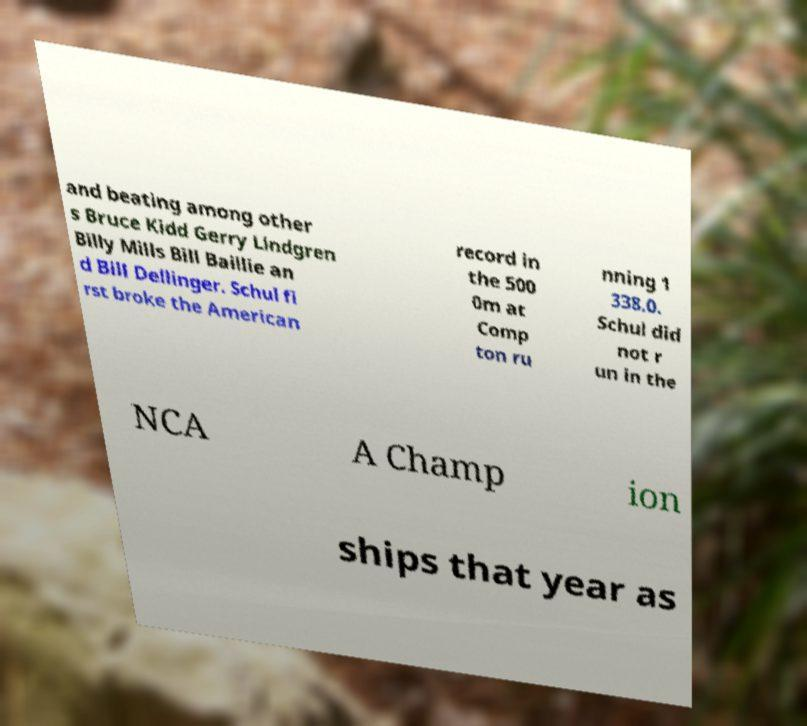There's text embedded in this image that I need extracted. Can you transcribe it verbatim? and beating among other s Bruce Kidd Gerry Lindgren Billy Mills Bill Baillie an d Bill Dellinger. Schul fi rst broke the American record in the 500 0m at Comp ton ru nning 1 338.0. Schul did not r un in the NCA A Champ ion ships that year as 